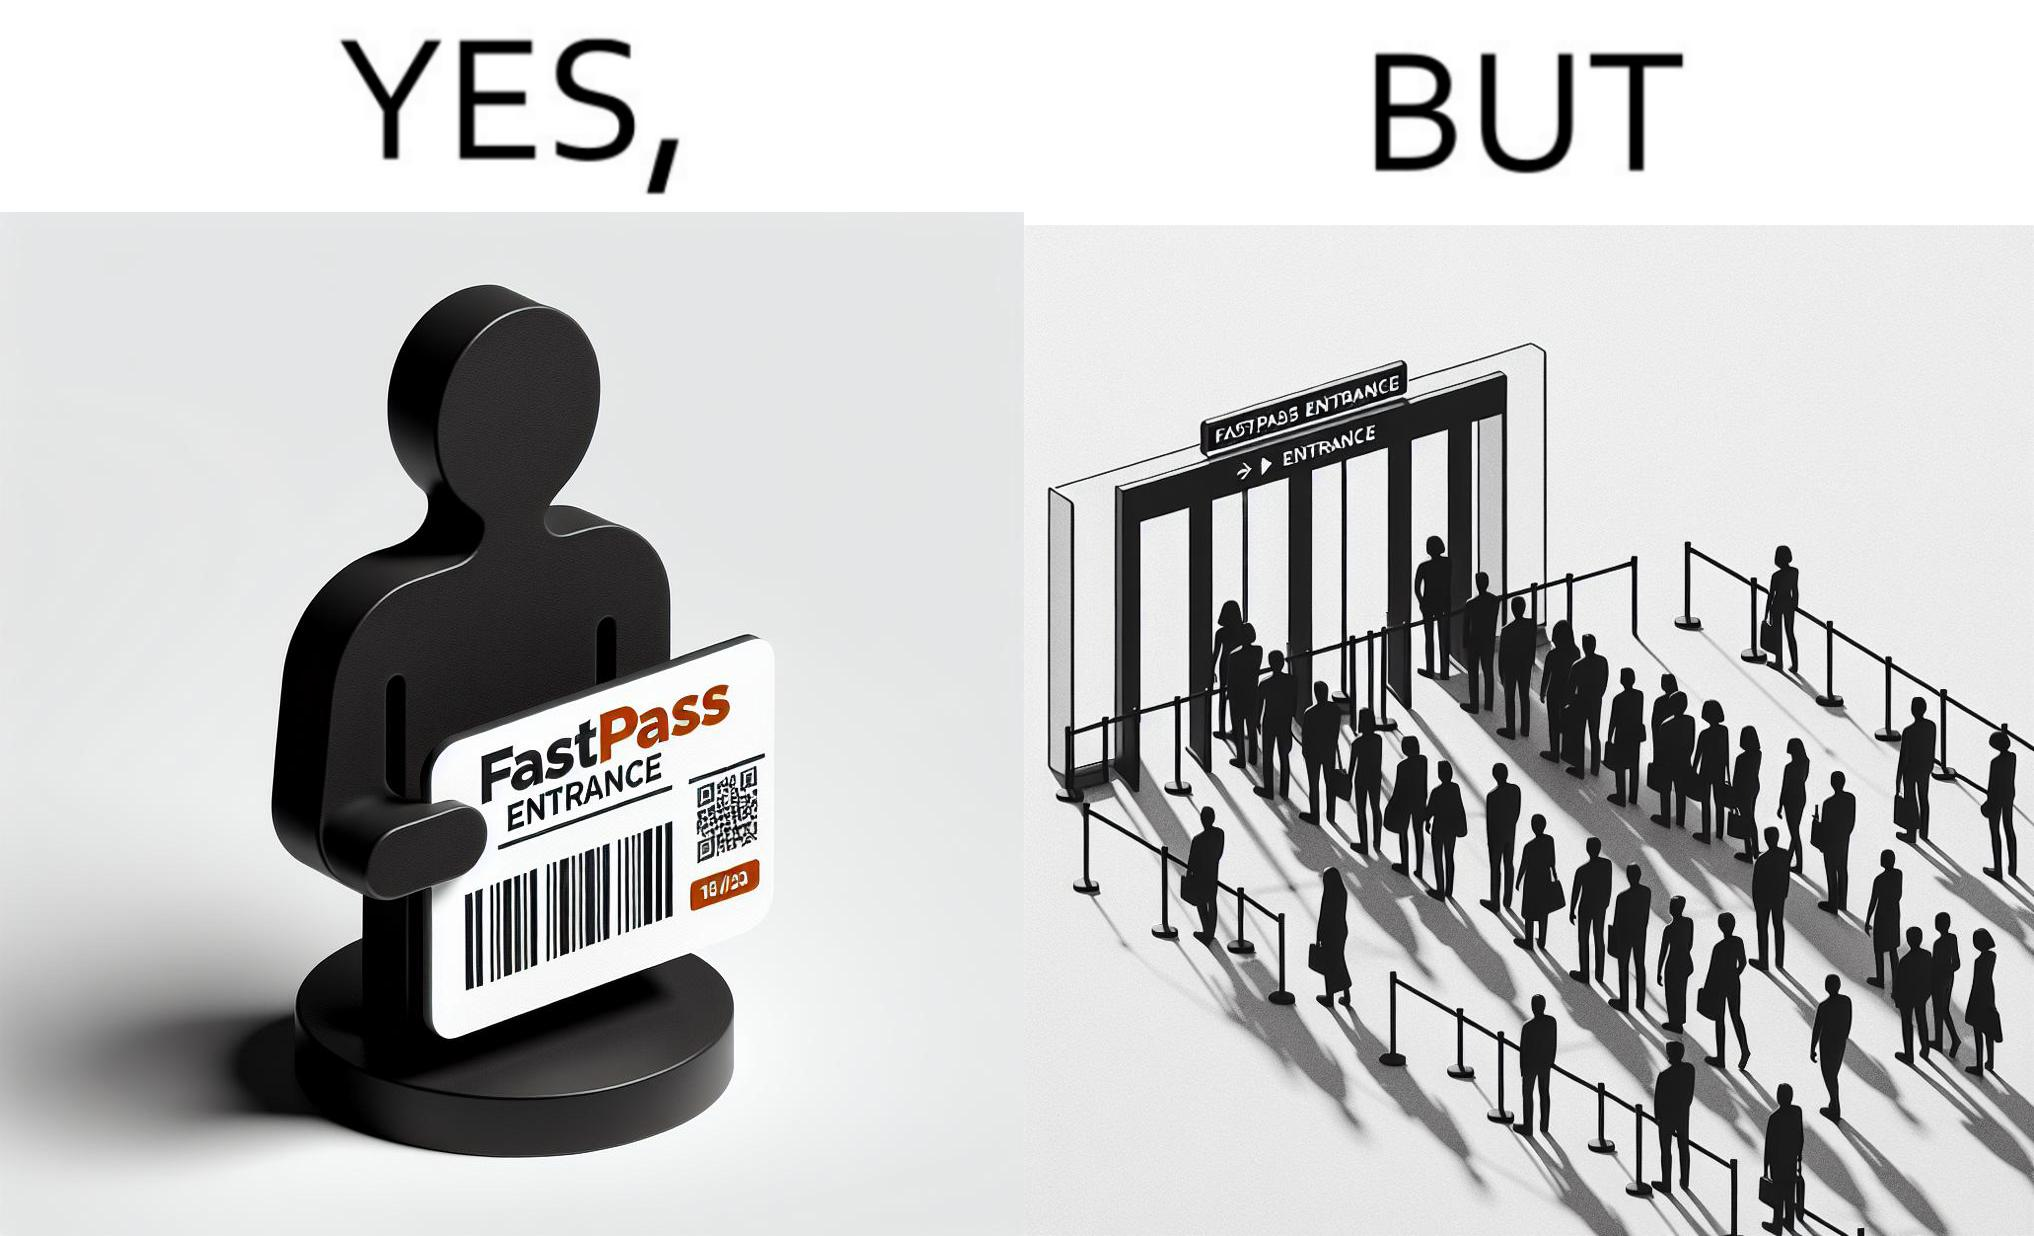What makes this image funny or satirical? The image is ironic, because fast pass entrance was meant for people to pass the gate fast but as more no. of people bought the pass due to which the queue has become longer and it becomes slow and time consuming 